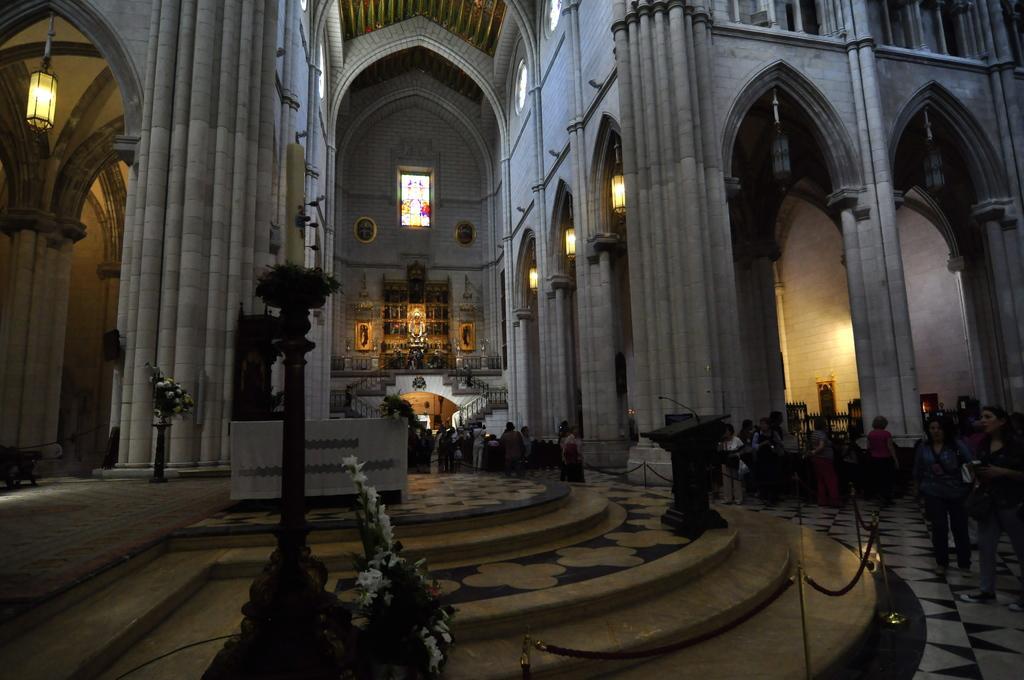Can you describe this image briefly? This is an inside picture of a building, in the building we can see a few people, there are some poles, lights, flower bouquets, pillars, grille and stands, in the background, we can see a photo frame on the wall and also there is a statue. 